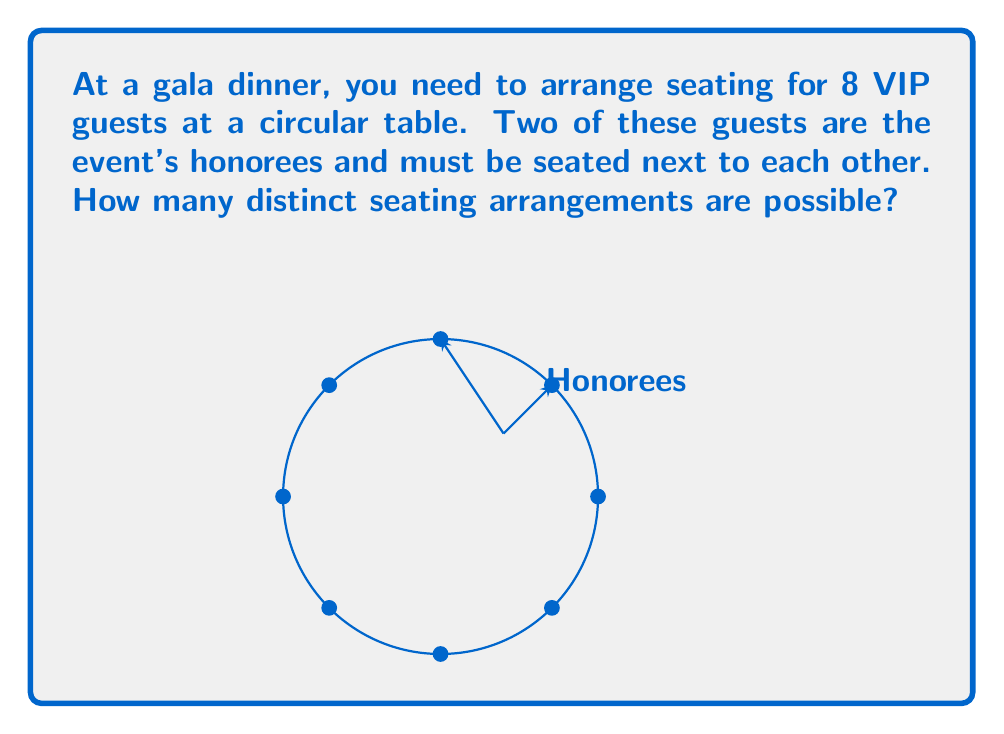Show me your answer to this math problem. Let's approach this step-by-step:

1) First, consider the honorees as a single unit. This reduces our problem to arranging 7 units (the honoree pair and 6 individual guests).

2) For a circular table with 7 units, we can use the formula for circular permutations:
   $$(n-1)! = (7-1)! = 6! = 720$$

3) However, we need to consider that the honorees can swap positions. This doubles our possibilities:
   $$720 \times 2 = 1440$$

4) Now, let's verify using the multiplication principle:
   a) We have 8 positions for the first honoree: 8 choices
   b) The second honoree must sit next to the first: 2 choices
   c) The remaining 6 guests can be arranged in 6! ways

   Thus, we have: $$8 \times 2 \times 6! = 8 \times 2 \times 720 = 11520$$

5) But in a circular arrangement, rotations of the same arrangement are considered identical. We've overcounted by a factor of 8 (the total number of seats).

6) Therefore, we divide our result by 8:
   $$\frac{11520}{8} = 1440$$

This confirms our earlier calculation.
Answer: 1440 distinct seating arrangements 